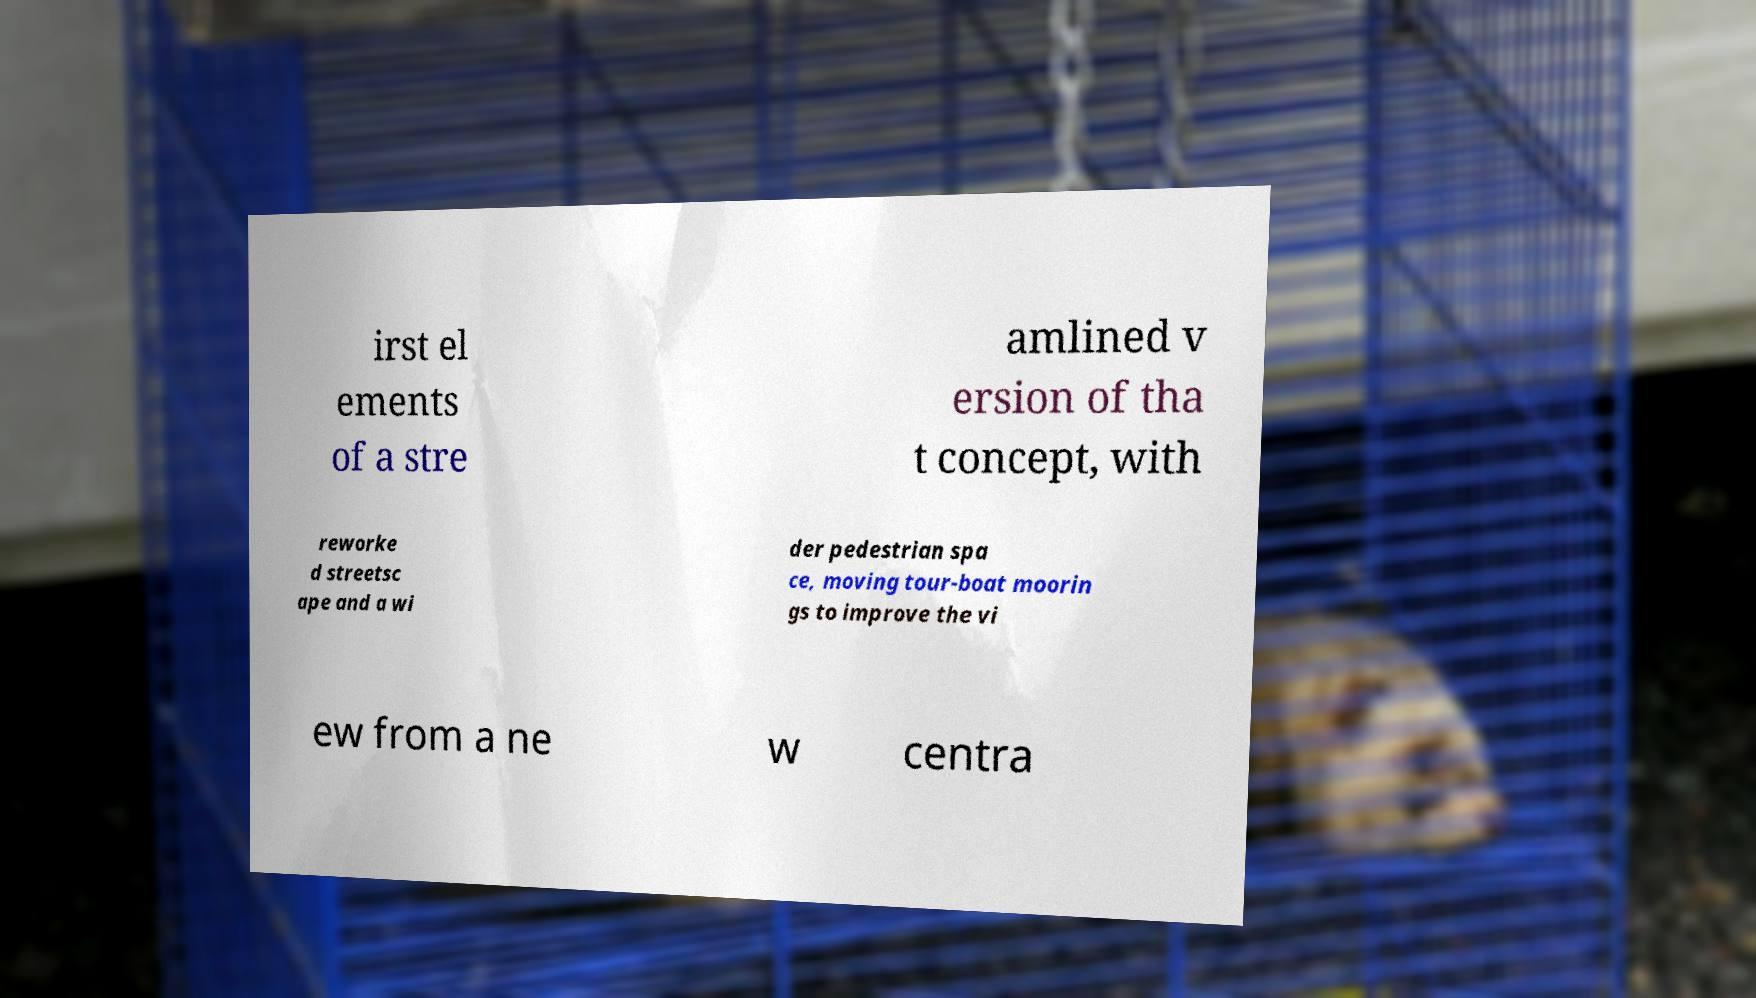Please read and relay the text visible in this image. What does it say? irst el ements of a stre amlined v ersion of tha t concept, with reworke d streetsc ape and a wi der pedestrian spa ce, moving tour-boat moorin gs to improve the vi ew from a ne w centra 